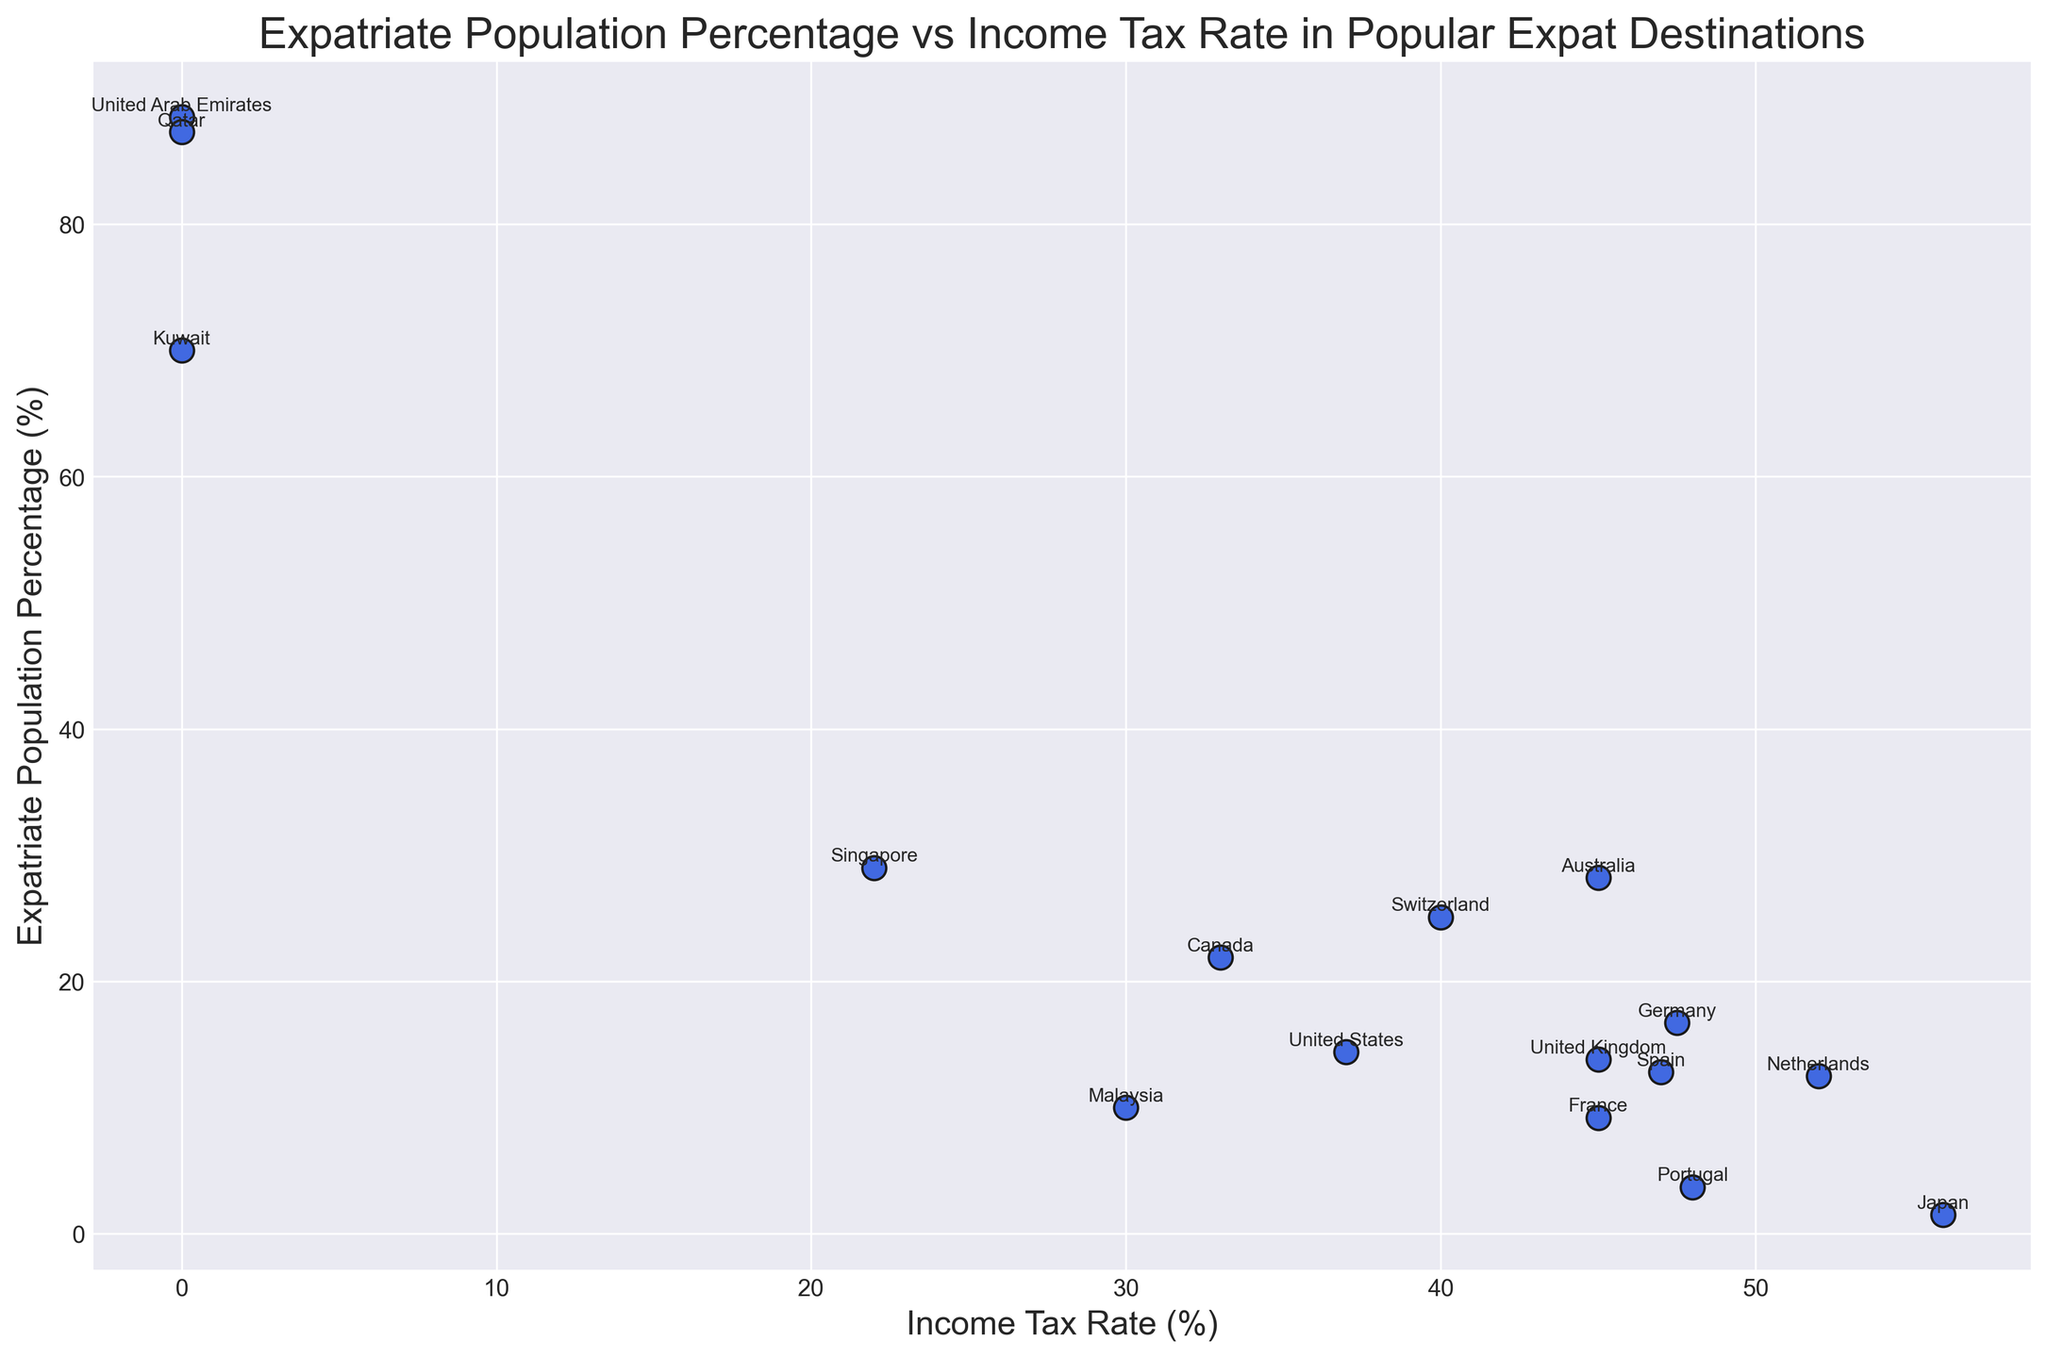How many countries have an income tax rate of 0%? To find the answer, look at the scatter plot and identify the points that have an x-value (Income Tax Rate) of 0. Count these points.
Answer: 3 Among the countries listed, which has the highest expatriate population percentage? To find the country with the highest expatriate population, look for the point with the highest y-value (Expatriate Population Percentage) on the scatter plot.
Answer: United Arab Emirates What is the average income tax rate for countries with an expatriate population percentage above 20%? Identify the countries with an expatriate population percentage above 20% from the scatter plot. Sum their income tax rates and divide by the number of these countries. Countries: UAE (0%), Qatar (0%), Kuwait (0%), Singapore (22%), Switzerland (40%), Canada (33%), Australia (45%). Average = (0+0+0+22+40+33+45) / 7 = 140 / 7 = 20%
Answer: 20% Compare the countries with the lowest and highest income tax rates. What are their expatriate population percentages? Identify the country with the lowest income tax rate (UAE, Qatar, Kuwait) with 0% and the highest (Japan) with 55.95%. Check their y-values for expatriate population percentages.
Answer: Lowest: UAE, Qatar, Kuwait (88.5%, 87.3%, 70.0%); Highest: Japan (1.5%) Which countries have a higher expatriate population percentage than the United States? Identify the y-value for the United States (Expatriate Population Percentage = 14.4%) on the scatter plot. Check which points have a higher y-value than this.
Answer: UAE, Qatar, Kuwait, Singapore, Switzerland, Canada, Australia Is there any noticeable relationship between the income tax rate and the expatriate population percentage? By visually inspecting the scatter plot, note that countries with low income tax rates (0%) have the highest expatriate population percentages, indicating an inverse relationship.
Answer: Inverse relationship What is the range of expatriate population percentages in countries with an income tax rate above 40%? Identify the countries with income tax rates above 40% (Netherlands, Germany, France, Australia, Portugal, Japan). Note their expatriate population percentages and find the range (Max - Min). Percentages: Netherlands (12.5%), Germany (16.7%), France (9.2%), Australia (28.2%), Portugal (3.7%), Japan (1.5%). Range: 28.2% - 1.5% = 26.7%
Answer: 26.7% What is the title of the scatter plot? Look at the title above the scatter plot, which summarizes the content of the chart.
Answer: Expatriate Population Percentage vs Income Tax Rate in Popular Expat Destinations How many data points represent countries with an expatriate population percentage lower than 10%? Identify the points on the scatter plot with y-values (Expatriate Population Percentage) below 10% and count them.
Answer: 4 Which country has both a relatively high income tax rate and a high expatriate population percentage? Look for countries on the scatter plot with a high x-value (Income Tax Rate) and a high y-value (Expatriate Population Percentage). Australia, with a 45% tax rate and a 28.2% expatriate population, fits this criterion.
Answer: Australia 